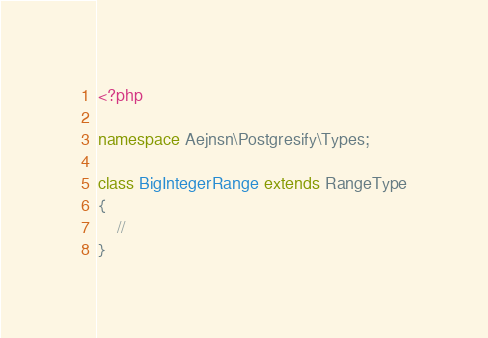Convert code to text. <code><loc_0><loc_0><loc_500><loc_500><_PHP_><?php

namespace Aejnsn\Postgresify\Types;

class BigIntegerRange extends RangeType
{
    //
}
</code> 